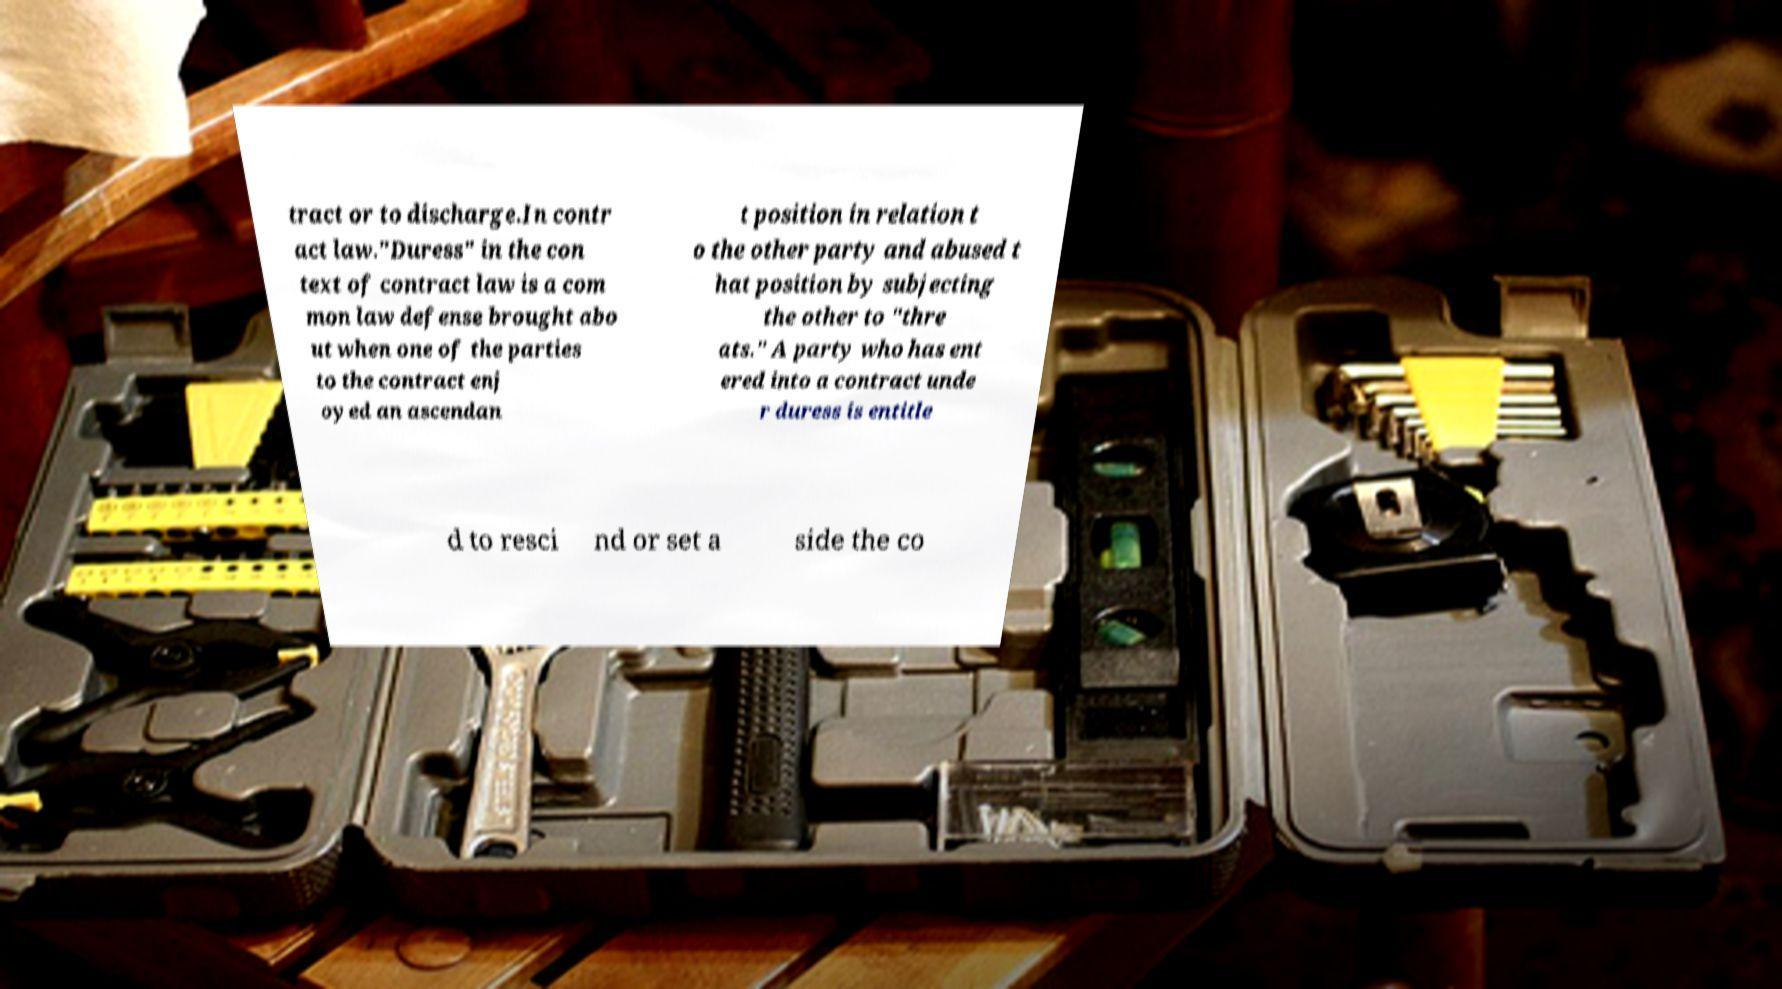Could you extract and type out the text from this image? tract or to discharge.In contr act law."Duress" in the con text of contract law is a com mon law defense brought abo ut when one of the parties to the contract enj oyed an ascendan t position in relation t o the other party and abused t hat position by subjecting the other to "thre ats." A party who has ent ered into a contract unde r duress is entitle d to resci nd or set a side the co 